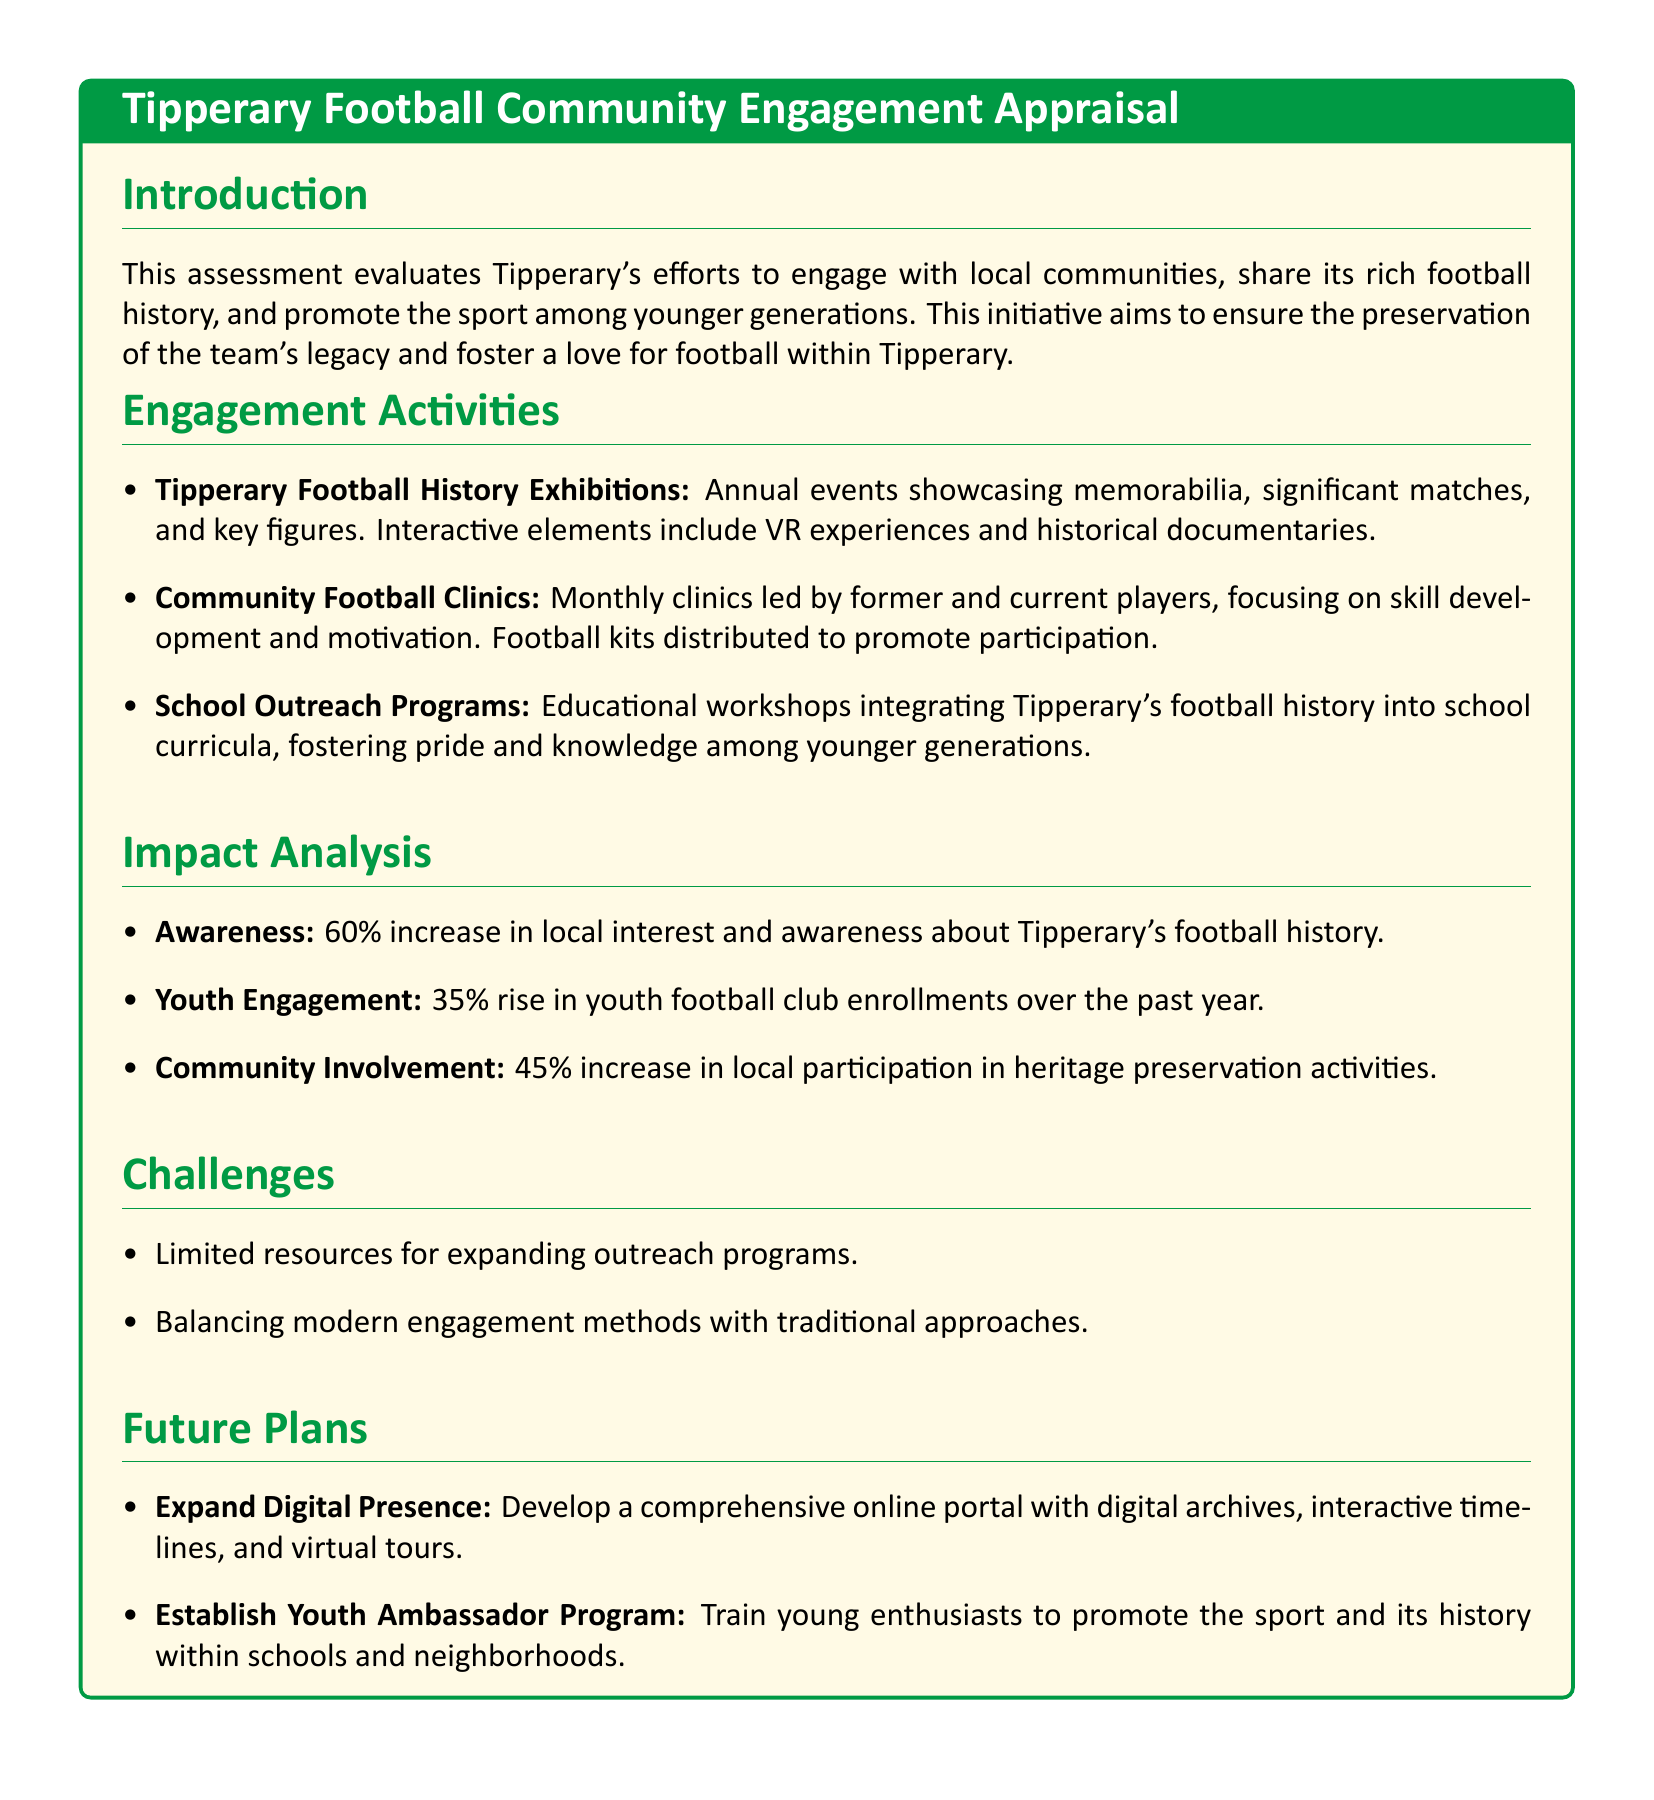What is the main purpose of the assessment? The assessment aims to evaluate Tipperary's efforts in engaging local communities, sharing football history, and promoting the sport.
Answer: Engage local communities What percentage increase in local interest occurred? The document states there was a 60% increase in local interest and awareness about Tipperary's football history.
Answer: 60% What type of clinics are organized monthly? The document mentions Community Football Clinics, which focus on skill development and motivation.
Answer: Community Football Clinics What is planned for future digital engagement? The future plans include developing a comprehensive online portal with digital archives and virtual tours.
Answer: Online portal What challenge is mentioned regarding outreach programs? Limited resources for expanding outreach programs is identified as a challenge in the document.
Answer: Limited resources What was the rise in youth club enrollments? The document indicates a 35% rise in youth football club enrollments over the past year.
Answer: 35% What educational initiative is included in the outreach efforts? The document describes School Outreach Programs that integrate Tipperary's football history into curricula.
Answer: School Outreach Programs What increase in participation in heritage activities is noted? The document reports a 45% increase in local participation in heritage preservation activities.
Answer: 45% What new program is proposed to promote youth engagement? The Future Plans section mentions establishing a Youth Ambassador Program to promote the sport.
Answer: Youth Ambassador Program 